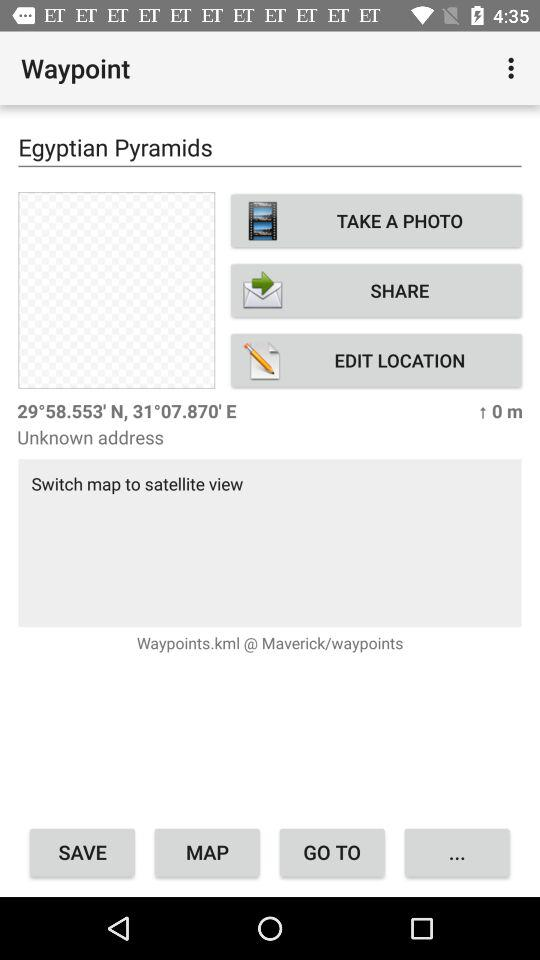What is the latitude and longitude of the waypoint?
Answer the question using a single word or phrase. 29°58.553' N, 31°07.870' E 